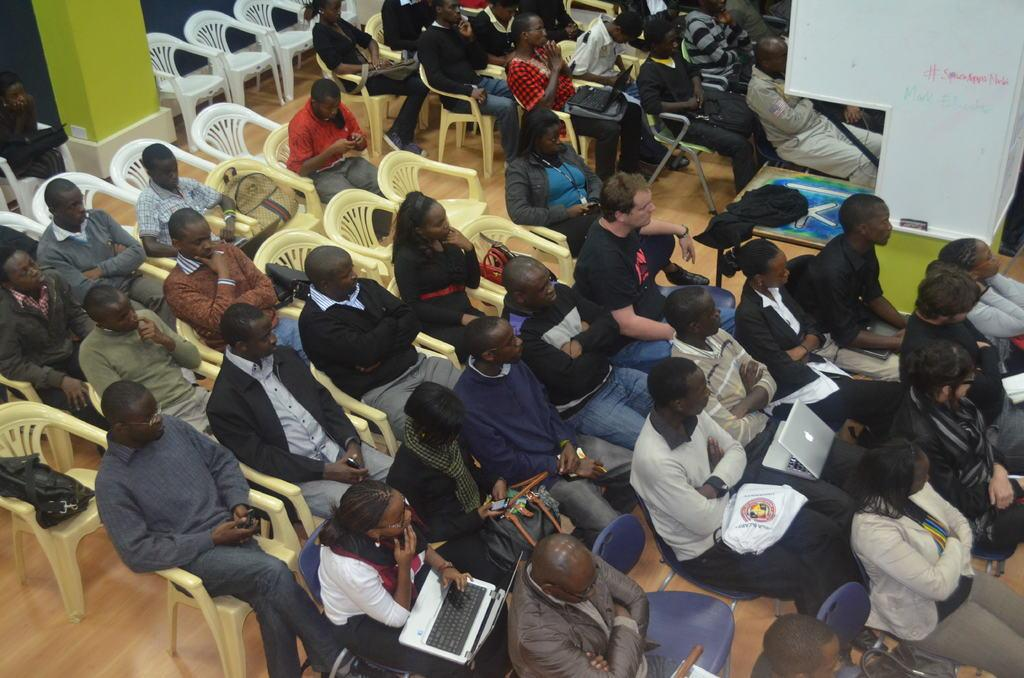What are the people in the image doing? The people in the image are sitting on chairs. What objects do the people have on their laps? The people have laptops and bags on their laps. What type of soup is being served in the image? There is no soup present in the image. How are the bags being used in the image? The bags are not being used in any specific way in the image; they are simply resting on the people's laps. 